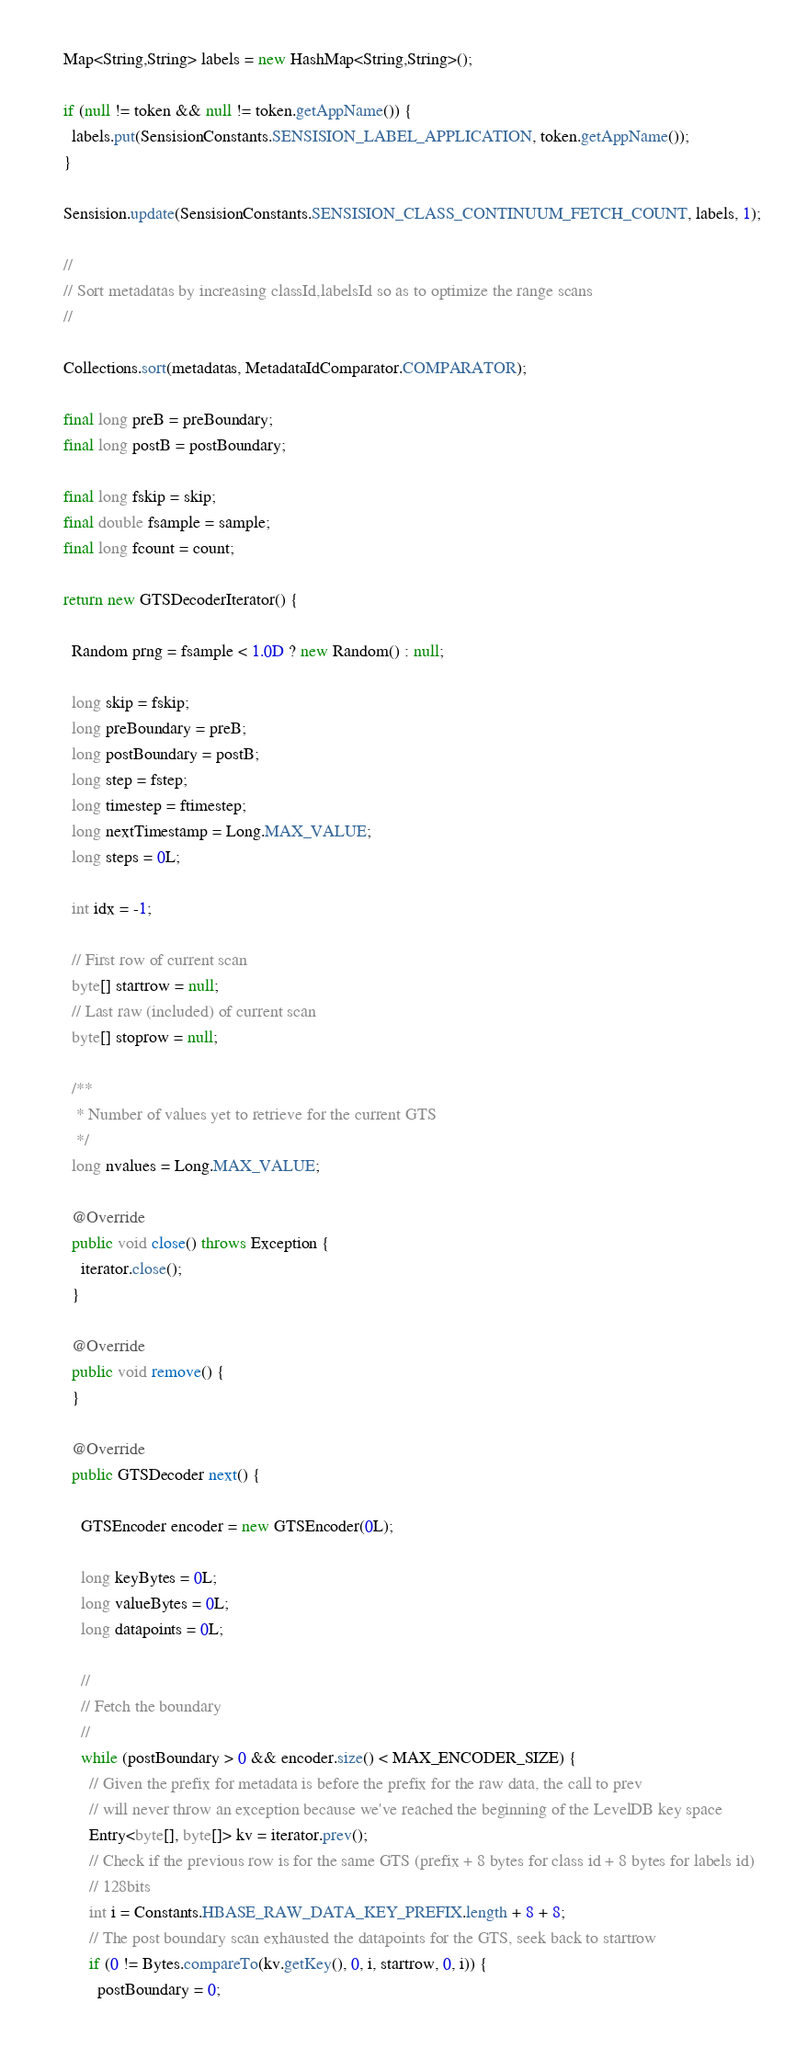<code> <loc_0><loc_0><loc_500><loc_500><_Java_>    Map<String,String> labels = new HashMap<String,String>();
    
    if (null != token && null != token.getAppName()) {
      labels.put(SensisionConstants.SENSISION_LABEL_APPLICATION, token.getAppName());
    }
    
    Sensision.update(SensisionConstants.SENSISION_CLASS_CONTINUUM_FETCH_COUNT, labels, 1);

    //
    // Sort metadatas by increasing classId,labelsId so as to optimize the range scans
    //
    
    Collections.sort(metadatas, MetadataIdComparator.COMPARATOR);
        
    final long preB = preBoundary;
    final long postB = postBoundary;

    final long fskip = skip;
    final double fsample = sample;
    final long fcount = count;
     
    return new GTSDecoderIterator() {
    
      Random prng = fsample < 1.0D ? new Random() : null;
      
      long skip = fskip;
      long preBoundary = preB;
      long postBoundary = postB;
      long step = fstep;
      long timestep = ftimestep;
      long nextTimestamp = Long.MAX_VALUE;
      long steps = 0L;
      
      int idx = -1;
       
      // First row of current scan      
      byte[] startrow = null;
      // Last raw (included) of current scan
      byte[] stoprow = null;
      
      /**
       * Number of values yet to retrieve for the current GTS
       */ 
      long nvalues = Long.MAX_VALUE;
      
      @Override
      public void close() throws Exception {
        iterator.close();
      }
      
      @Override
      public void remove() {        
      }
      
      @Override
      public GTSDecoder next() {
                
        GTSEncoder encoder = new GTSEncoder(0L);

        long keyBytes = 0L;
        long valueBytes = 0L;
        long datapoints = 0L;
        
        //
        // Fetch the boundary
        //
        while (postBoundary > 0 && encoder.size() < MAX_ENCODER_SIZE) {
          // Given the prefix for metadata is before the prefix for the raw data, the call to prev
          // will never throw an exception because we've reached the beginning of the LevelDB key space
          Entry<byte[], byte[]> kv = iterator.prev();
          // Check if the previous row is for the same GTS (prefix + 8 bytes for class id + 8 bytes for labels id)
          // 128bits
          int i = Constants.HBASE_RAW_DATA_KEY_PREFIX.length + 8 + 8;
          // The post boundary scan exhausted the datapoints for the GTS, seek back to startrow
          if (0 != Bytes.compareTo(kv.getKey(), 0, i, startrow, 0, i)) {
            postBoundary = 0;</code> 